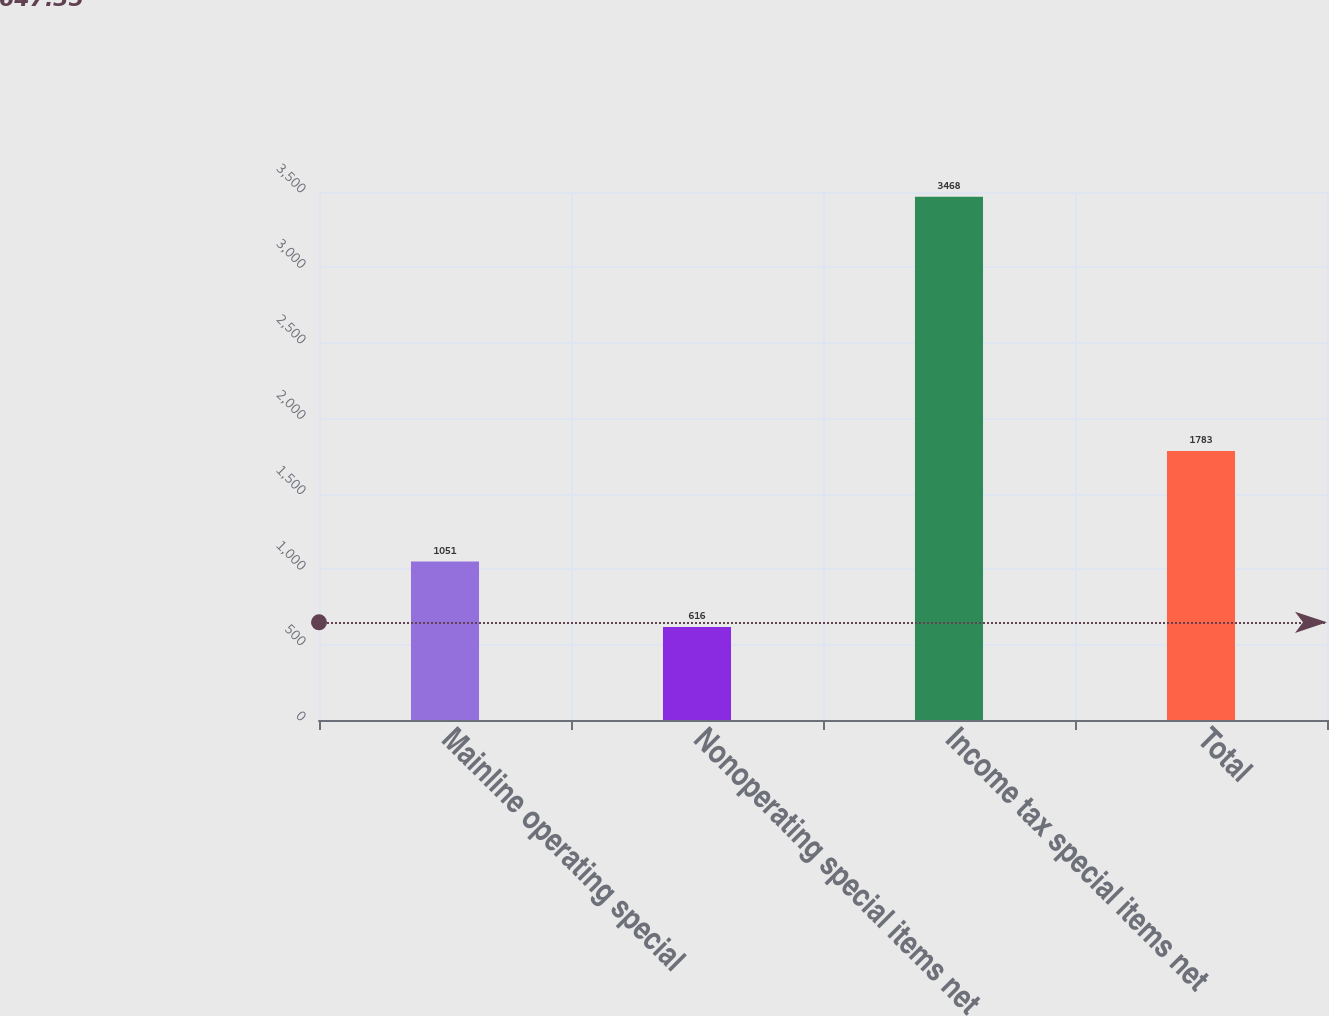Convert chart. <chart><loc_0><loc_0><loc_500><loc_500><bar_chart><fcel>Mainline operating special<fcel>Nonoperating special items net<fcel>Income tax special items net<fcel>Total<nl><fcel>1051<fcel>616<fcel>3468<fcel>1783<nl></chart> 